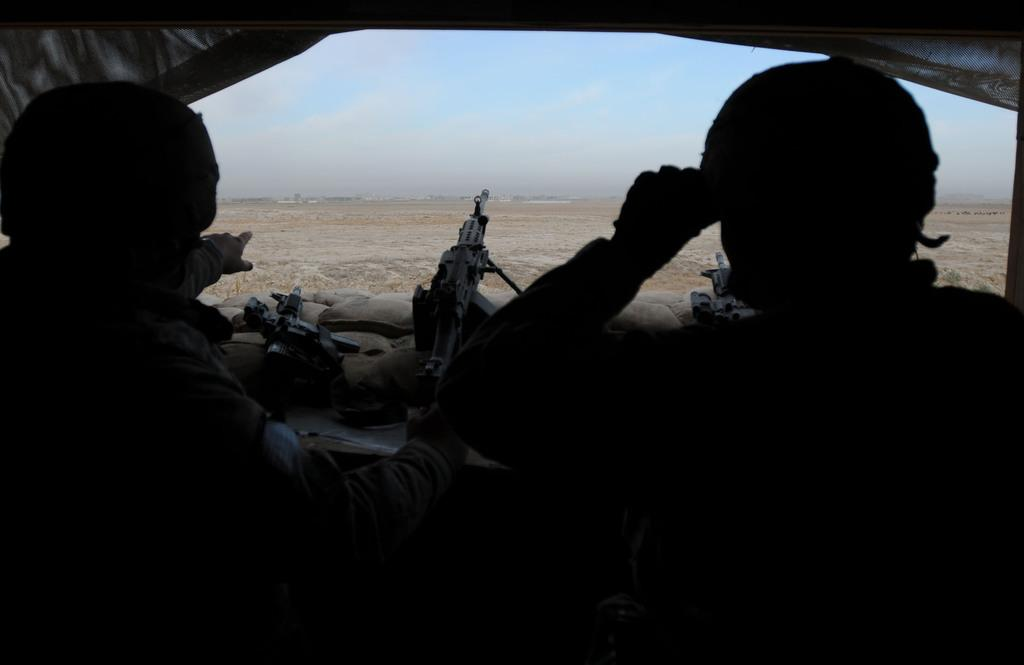How many people are in the image? There are two people in the image. What are the people holding in their hands? The people are holding guns. What can be seen in the background of the image? The sky is visible in the image. What objects are in front of the people? There are bags in front of the people. What type of snow can be seen falling in the image? There is no snow present in the image. What print can be seen on the bags in front of the people? There is no print visible on the bags in the image. 